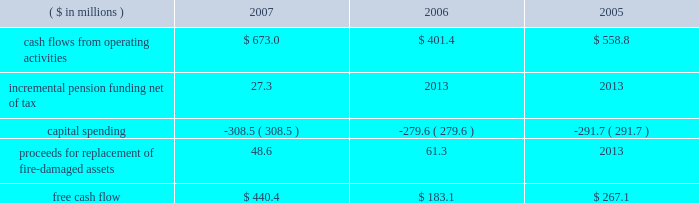Page 30 of 94 are included in capital spending amounts .
Another example is the company 2019s decision in 2007 to contribute an additional $ 44.5 million ( $ 27.3 million ) to its pension plans as part of its overall debt reduction plan .
Based on this , our consolidated free cash flow is summarized as follows: .
Based on information currently available , we estimate cash flows from operating activities for 2008 to be approximately $ 650 million , capital spending to be approximately $ 350 million and free cash flow to be in the $ 300 million range .
Capital spending of $ 259.9 million ( net of $ 48.6 million in insurance recoveries ) in 2007 was below depreciation and amortization expense of $ 281 million .
We continue to invest capital in our best performing operations , including projects to increase custom can capabilities , improve beverage can and end making productivity and add more beverage can capacity in europe , as well as expenditures in the aerospace and technologies segment .
Of the $ 350 million of planned capital spending for 2008 , approximately $ 180 million will be spent on top-line sales growth projects .
Debt facilities and refinancing interest-bearing debt at december 31 , 2007 , decreased $ 93.1 million to $ 2358.6 million from $ 2451.7 million at december 31 , 2006 .
The 2007 debt decrease from 2006 was primarily attributed to debt payments offset by higher foreign exchange rates .
At december 31 , 2007 , $ 705 million was available under the company 2019s multi-currency revolving credit facilities .
The company also had $ 345 million of short-term uncommitted credit facilities available at the end of the year , of which $ 49.7 million was outstanding .
On october 13 , 2005 , ball refinanced its senior secured credit facilities and during the third and fourth quarters of 2005 , ball redeemed its 7.75% ( 7.75 % ) senior notes due august 2006 primarily through the drawdown of funds under the new credit facilities .
The refinancing and redemption resulted in a pretax debt refinancing charge of $ 19.3 million ( $ 12.3 million after tax ) to reflect the call premium associated with the senior notes and the write off of unamortized debt issuance costs .
The company has a receivables sales agreement that provides for the ongoing , revolving sale of a designated pool of trade accounts receivable of ball 2019s north american packaging operations , up to $ 250 million .
The agreement qualifies as off-balance sheet financing under the provisions of statement of financial accounting standards ( sfas ) no .
140 , as amended by sfas no .
156 .
Net funds received from the sale of the accounts receivable totaled $ 170 million and $ 201.3 million at december 31 , 2007 and 2006 , respectively , and are reflected as a reduction of accounts receivable in the consolidated balance sheets .
The company was not in default of any loan agreement at december 31 , 2007 , and has met all payment obligations .
The u.s .
Note agreements , bank credit agreement and industrial development revenue bond agreements contain certain restrictions relating to dividends , investments , financial ratios , guarantees and the incurrence of additional indebtedness .
Additional details about the company 2019s receivables sales agreement and debt are available in notes 7 and 13 , respectively , accompanying the consolidated financial statements within item 8 of this report. .
What is the percentage change in capital spending from 2006 to 2007? 
Computations: ((308.5 - 279.6) / 279.6)
Answer: 0.10336. 